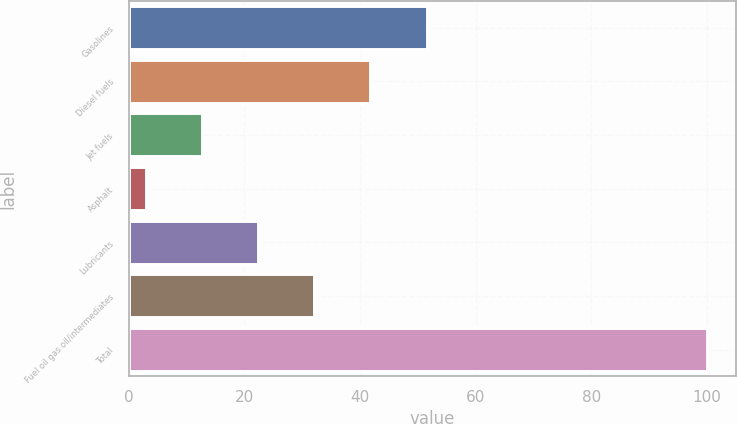Convert chart to OTSL. <chart><loc_0><loc_0><loc_500><loc_500><bar_chart><fcel>Gasolines<fcel>Diesel fuels<fcel>Jet fuels<fcel>Asphalt<fcel>Lubricants<fcel>Fuel oil gas oil/intermediates<fcel>Total<nl><fcel>51.5<fcel>41.8<fcel>12.7<fcel>3<fcel>22.4<fcel>32.1<fcel>100<nl></chart> 